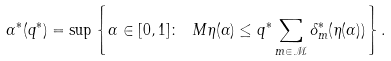<formula> <loc_0><loc_0><loc_500><loc_500>\alpha ^ { * } ( q ^ { * } ) = \sup \left \{ \alpha \in [ 0 , 1 ] \colon \ M \eta ( \alpha ) \leq q ^ { * } \sum _ { m \in \mathcal { M } } \delta _ { m } ^ { * } ( \eta ( \alpha ) ) \right \} .</formula> 